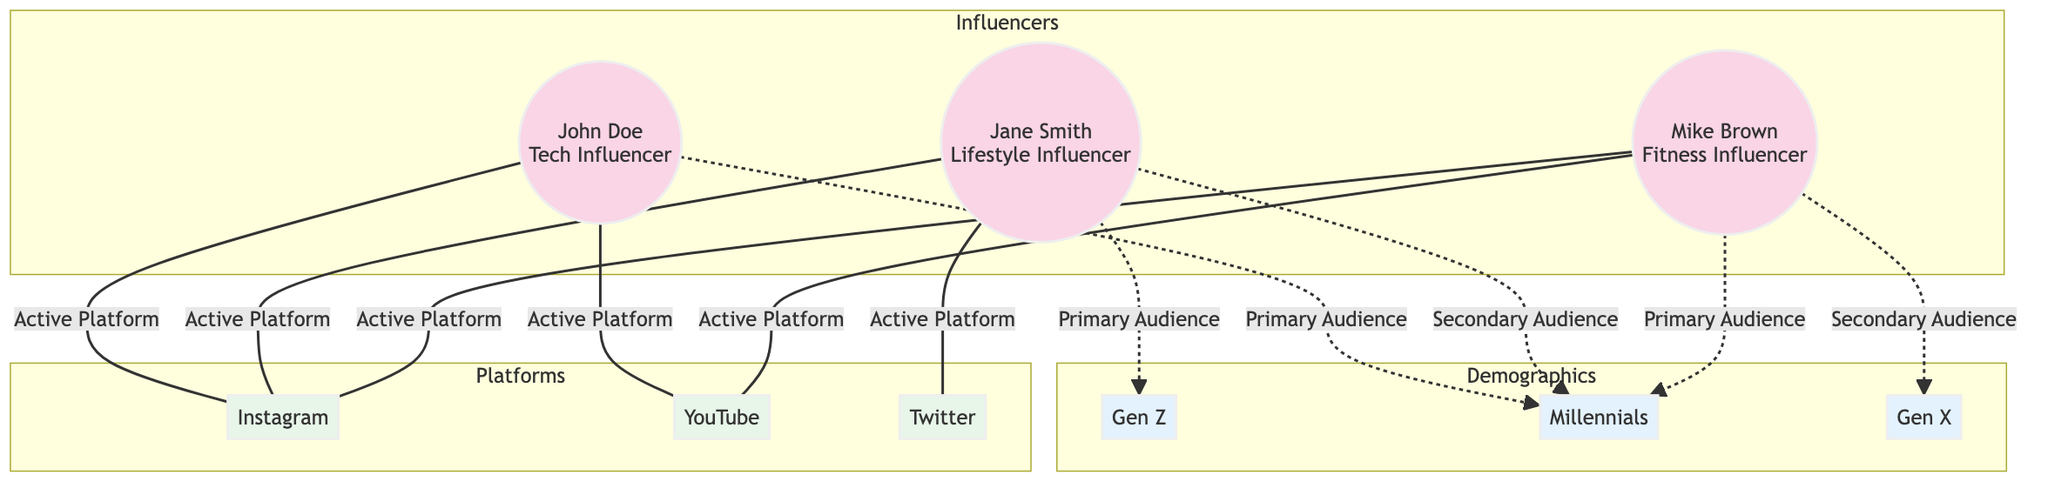What is the primary audience for John Doe? The edge labeled "Primary Audience" connects John Doe to the demographic "Millennials."
Answer: Millennials How many influencers are represented in the diagram? There are three nodes representing influencers: John Doe, Jane Smith, and Mike Brown.
Answer: 3 Which platform is used by both Jane Smith and Mike Brown? The edge labeled "Active Platform" shows that both influencers are connected to Instagram.
Answer: Instagram What demographic is the primary audience for Jane Smith? The edge labeled "Primary Audience" connects Jane Smith to the demographic "Gen Z."
Answer: Gen Z How many active platforms does Mike Brown use? The diagram indicates that Mike Brown is connected to two platforms: YouTube and Instagram, via the edges labeled "Active Platform."
Answer: 2 Which influencer has a secondary audience in Millennials? Jane Smith has a secondary audience connection to Millennials, as shown by the edge labeled "Secondary Audience."
Answer: Jane Smith What is the relationship between Mike Brown and Gen X? The edge labeled "Secondary Audience" links Mike Brown to the demographic Gen X.
Answer: Secondary Audience Which demographic has the most influencers connected as their primary audience? The demographic "Millennials" has two influencers (John Doe and Mike Brown) connected to it as primary audiences.
Answer: Millennials Which platform is exclusively associated with Mike Brown? There is no platform uniquely associated with Mike Brown; he shares platforms with other influencers, particularly Instagram and YouTube.
Answer: None 